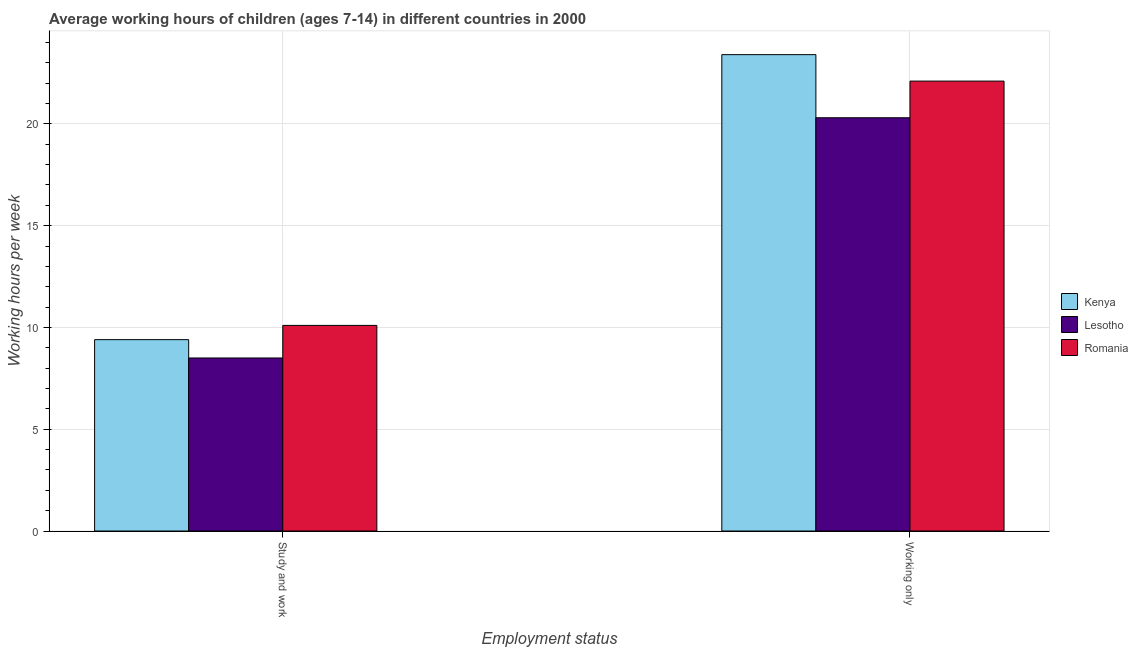Are the number of bars on each tick of the X-axis equal?
Offer a very short reply. Yes. How many bars are there on the 2nd tick from the left?
Ensure brevity in your answer.  3. How many bars are there on the 1st tick from the right?
Ensure brevity in your answer.  3. What is the label of the 1st group of bars from the left?
Offer a terse response. Study and work. What is the average working hour of children involved in only work in Lesotho?
Your answer should be compact. 20.3. Across all countries, what is the maximum average working hour of children involved in study and work?
Make the answer very short. 10.1. Across all countries, what is the minimum average working hour of children involved in study and work?
Provide a short and direct response. 8.5. In which country was the average working hour of children involved in study and work maximum?
Your answer should be very brief. Romania. In which country was the average working hour of children involved in study and work minimum?
Make the answer very short. Lesotho. What is the total average working hour of children involved in only work in the graph?
Keep it short and to the point. 65.8. What is the difference between the average working hour of children involved in study and work in Kenya and that in Lesotho?
Make the answer very short. 0.9. What is the difference between the average working hour of children involved in study and work in Kenya and the average working hour of children involved in only work in Romania?
Provide a succinct answer. -12.7. What is the average average working hour of children involved in study and work per country?
Keep it short and to the point. 9.33. What is the difference between the average working hour of children involved in only work and average working hour of children involved in study and work in Kenya?
Your answer should be very brief. 14. In how many countries, is the average working hour of children involved in study and work greater than 10 hours?
Your answer should be very brief. 1. What is the ratio of the average working hour of children involved in study and work in Lesotho to that in Romania?
Ensure brevity in your answer.  0.84. Is the average working hour of children involved in study and work in Lesotho less than that in Kenya?
Ensure brevity in your answer.  Yes. What does the 2nd bar from the left in Working only represents?
Your response must be concise. Lesotho. What does the 2nd bar from the right in Study and work represents?
Ensure brevity in your answer.  Lesotho. Are all the bars in the graph horizontal?
Your response must be concise. No. How many countries are there in the graph?
Make the answer very short. 3. What is the difference between two consecutive major ticks on the Y-axis?
Ensure brevity in your answer.  5. Does the graph contain grids?
Ensure brevity in your answer.  Yes. Where does the legend appear in the graph?
Provide a succinct answer. Center right. How are the legend labels stacked?
Provide a succinct answer. Vertical. What is the title of the graph?
Offer a terse response. Average working hours of children (ages 7-14) in different countries in 2000. Does "Peru" appear as one of the legend labels in the graph?
Your answer should be compact. No. What is the label or title of the X-axis?
Ensure brevity in your answer.  Employment status. What is the label or title of the Y-axis?
Your response must be concise. Working hours per week. What is the Working hours per week of Kenya in Working only?
Your response must be concise. 23.4. What is the Working hours per week of Lesotho in Working only?
Your response must be concise. 20.3. What is the Working hours per week in Romania in Working only?
Your answer should be very brief. 22.1. Across all Employment status, what is the maximum Working hours per week in Kenya?
Provide a short and direct response. 23.4. Across all Employment status, what is the maximum Working hours per week of Lesotho?
Your answer should be compact. 20.3. Across all Employment status, what is the maximum Working hours per week of Romania?
Offer a very short reply. 22.1. Across all Employment status, what is the minimum Working hours per week of Lesotho?
Ensure brevity in your answer.  8.5. What is the total Working hours per week in Kenya in the graph?
Your response must be concise. 32.8. What is the total Working hours per week in Lesotho in the graph?
Make the answer very short. 28.8. What is the total Working hours per week in Romania in the graph?
Your response must be concise. 32.2. What is the difference between the Working hours per week in Lesotho in Study and work and that in Working only?
Give a very brief answer. -11.8. What is the average Working hours per week in Lesotho per Employment status?
Offer a very short reply. 14.4. What is the difference between the Working hours per week of Kenya and Working hours per week of Romania in Study and work?
Offer a very short reply. -0.7. What is the difference between the Working hours per week of Lesotho and Working hours per week of Romania in Working only?
Offer a very short reply. -1.8. What is the ratio of the Working hours per week in Kenya in Study and work to that in Working only?
Keep it short and to the point. 0.4. What is the ratio of the Working hours per week in Lesotho in Study and work to that in Working only?
Your answer should be very brief. 0.42. What is the ratio of the Working hours per week in Romania in Study and work to that in Working only?
Ensure brevity in your answer.  0.46. What is the difference between the highest and the second highest Working hours per week of Kenya?
Your response must be concise. 14. What is the difference between the highest and the lowest Working hours per week in Romania?
Give a very brief answer. 12. 